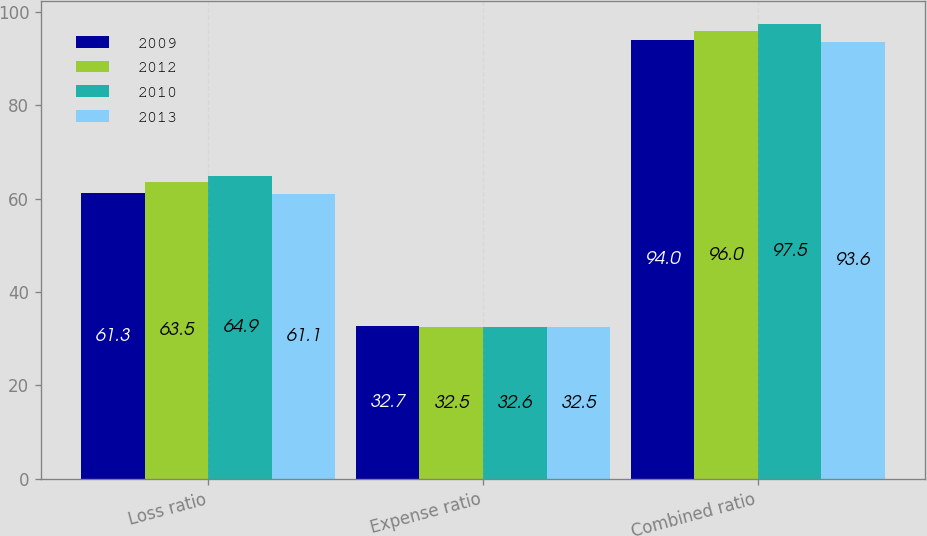<chart> <loc_0><loc_0><loc_500><loc_500><stacked_bar_chart><ecel><fcel>Loss ratio<fcel>Expense ratio<fcel>Combined ratio<nl><fcel>2009<fcel>61.3<fcel>32.7<fcel>94<nl><fcel>2012<fcel>63.5<fcel>32.5<fcel>96<nl><fcel>2010<fcel>64.9<fcel>32.6<fcel>97.5<nl><fcel>2013<fcel>61.1<fcel>32.5<fcel>93.6<nl></chart> 